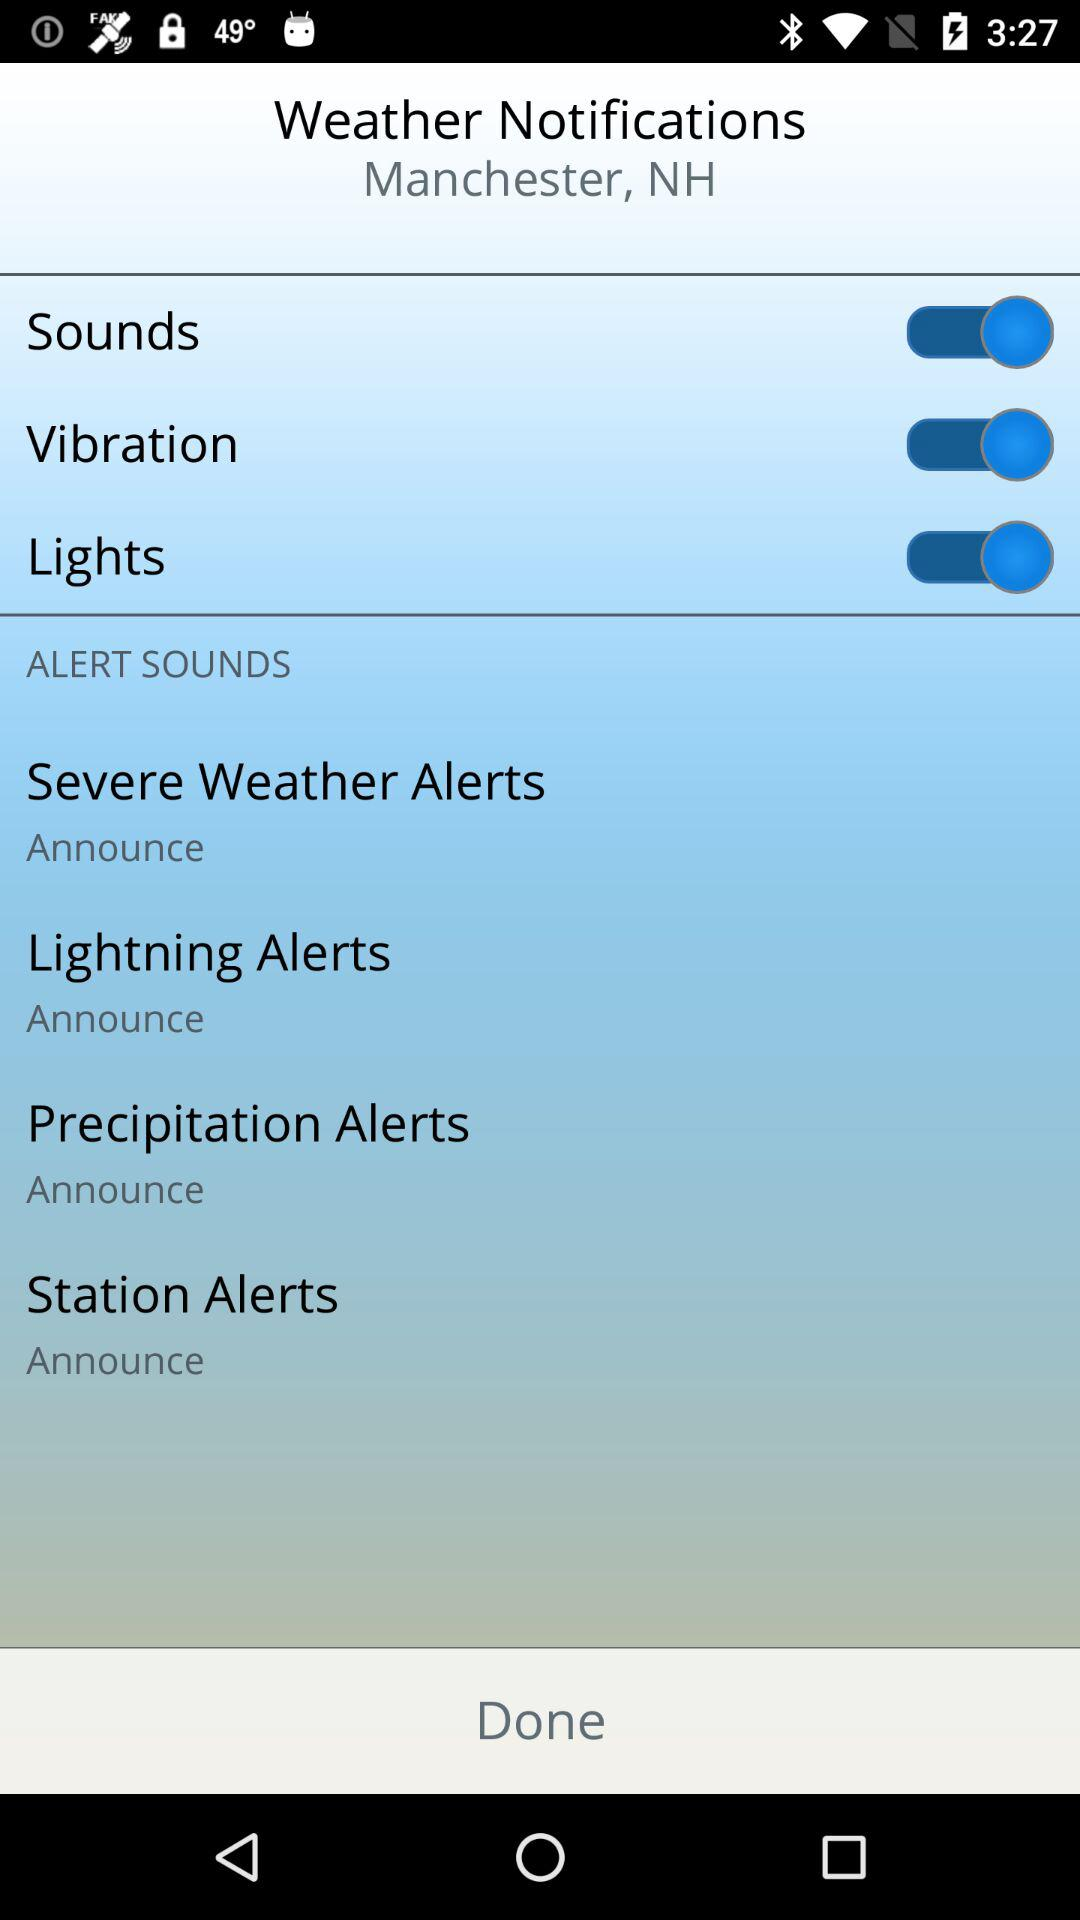What is the location? The location is Manchester, NH. 